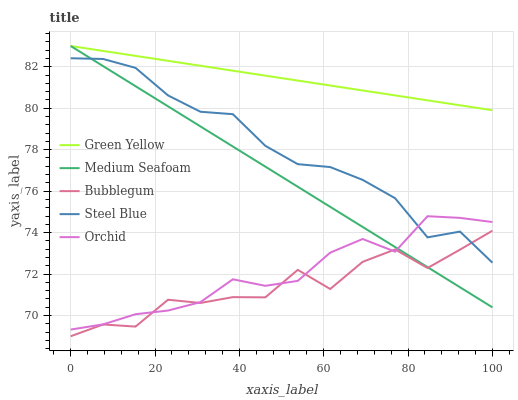Does Bubblegum have the minimum area under the curve?
Answer yes or no. Yes. Does Green Yellow have the maximum area under the curve?
Answer yes or no. Yes. Does Medium Seafoam have the minimum area under the curve?
Answer yes or no. No. Does Medium Seafoam have the maximum area under the curve?
Answer yes or no. No. Is Green Yellow the smoothest?
Answer yes or no. Yes. Is Bubblegum the roughest?
Answer yes or no. Yes. Is Medium Seafoam the smoothest?
Answer yes or no. No. Is Medium Seafoam the roughest?
Answer yes or no. No. Does Bubblegum have the lowest value?
Answer yes or no. Yes. Does Medium Seafoam have the lowest value?
Answer yes or no. No. Does Medium Seafoam have the highest value?
Answer yes or no. Yes. Does Bubblegum have the highest value?
Answer yes or no. No. Is Orchid less than Green Yellow?
Answer yes or no. Yes. Is Green Yellow greater than Bubblegum?
Answer yes or no. Yes. Does Medium Seafoam intersect Steel Blue?
Answer yes or no. Yes. Is Medium Seafoam less than Steel Blue?
Answer yes or no. No. Is Medium Seafoam greater than Steel Blue?
Answer yes or no. No. Does Orchid intersect Green Yellow?
Answer yes or no. No. 